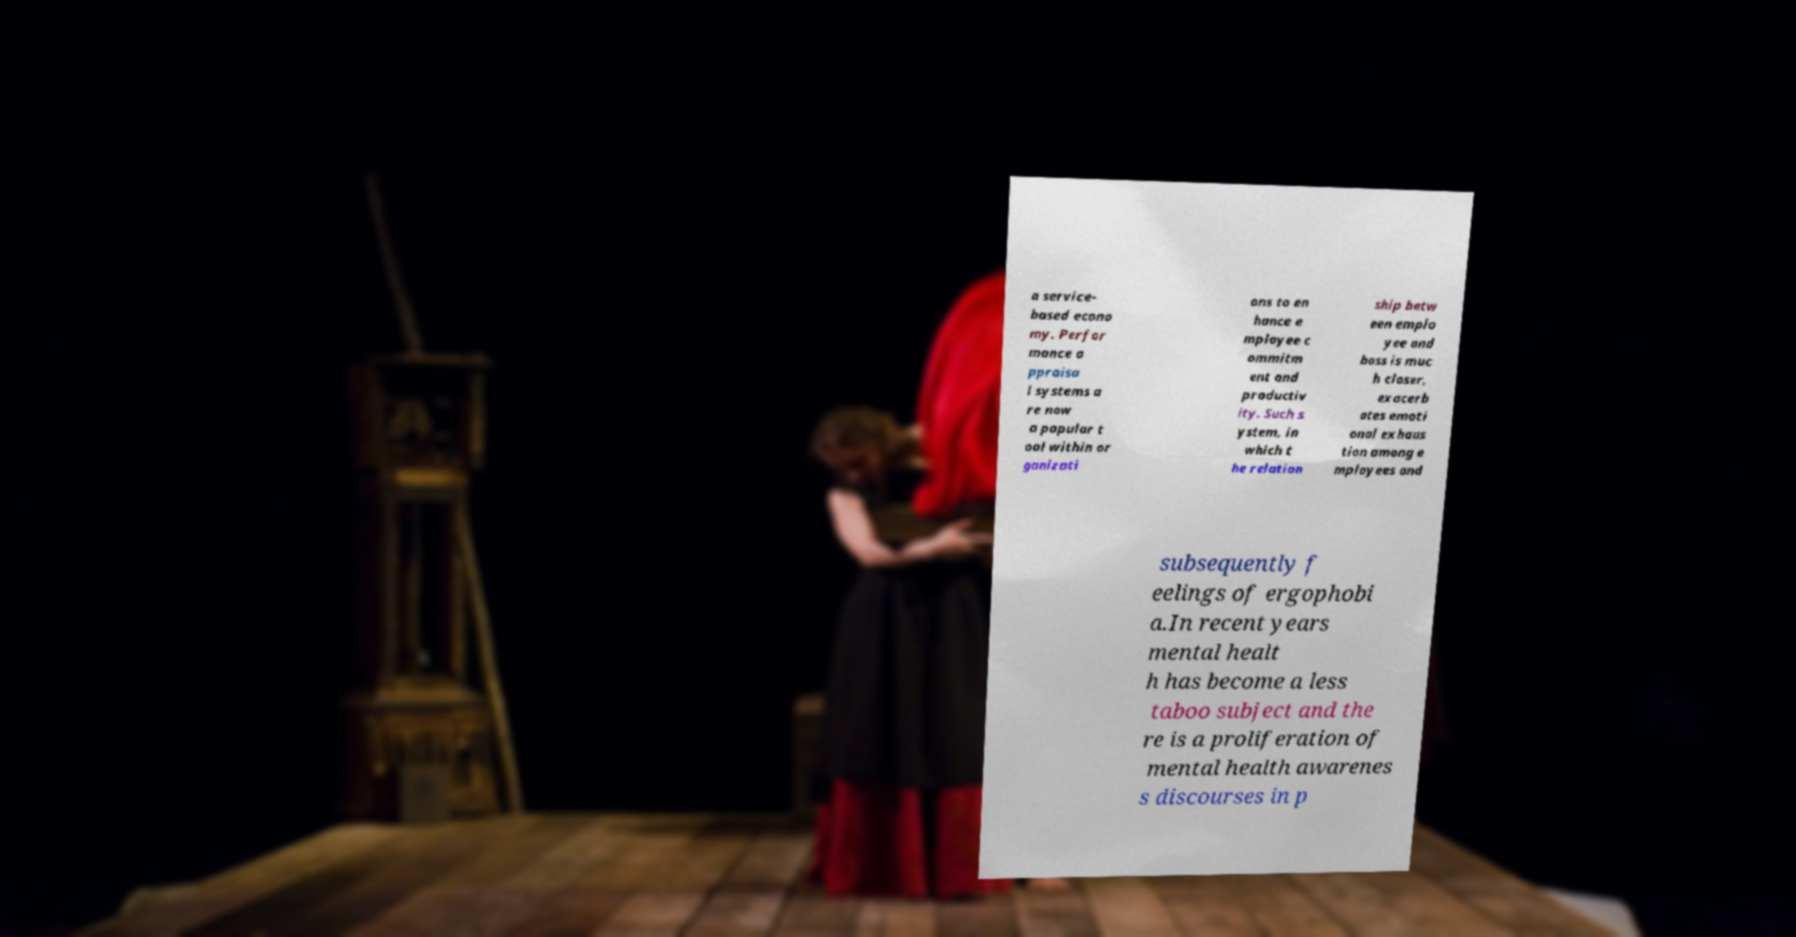What messages or text are displayed in this image? I need them in a readable, typed format. a service- based econo my. Perfor mance a ppraisa l systems a re now a popular t ool within or ganizati ons to en hance e mployee c ommitm ent and productiv ity. Such s ystem, in which t he relation ship betw een emplo yee and boss is muc h closer, exacerb ates emoti onal exhaus tion among e mployees and subsequently f eelings of ergophobi a.In recent years mental healt h has become a less taboo subject and the re is a proliferation of mental health awarenes s discourses in p 